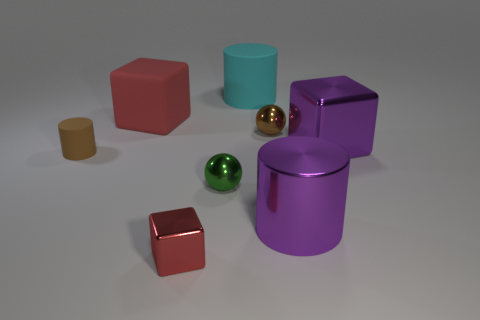Do the large shiny cylinder and the large metal cube have the same color?
Your answer should be compact. Yes. There is a tiny brown thing to the left of the tiny brown thing right of the brown rubber cylinder; what shape is it?
Provide a short and direct response. Cylinder. There is a brown thing that is the same shape as the large cyan thing; what size is it?
Your answer should be compact. Small. What is the color of the matte cylinder to the right of the red metallic cube?
Offer a very short reply. Cyan. The block right of the tiny metal sphere that is behind the large cube to the right of the cyan thing is made of what material?
Ensure brevity in your answer.  Metal. There is a red block that is in front of the sphere on the right side of the big cyan rubber cylinder; how big is it?
Provide a short and direct response. Small. There is a tiny thing that is the same shape as the large red thing; what is its color?
Offer a terse response. Red. What number of tiny things have the same color as the large metal cylinder?
Provide a succinct answer. 0. Is the green metal thing the same size as the brown ball?
Offer a very short reply. Yes. What is the material of the big cyan thing?
Offer a terse response. Rubber. 